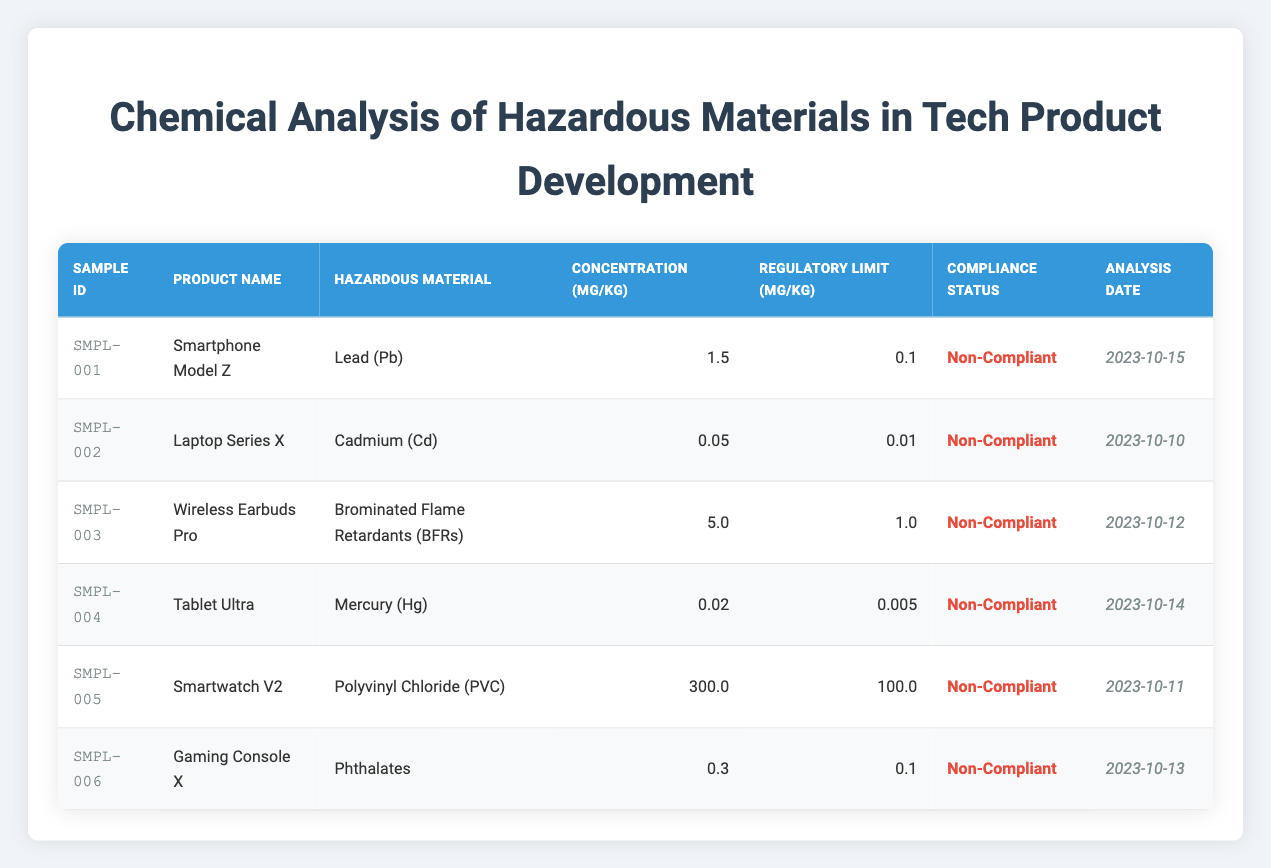What is the hazardous material found in Smartphone Model Z? The table lists the hazardous materials for each product. For Smartphone Model Z, the hazardous material is specified in the "Hazardous Material" column, which shows "Lead (Pb)."
Answer: Lead (Pb) Which product has the highest concentration of hazardous material? To find the highest concentration, we look at the "Concentration (mg/kg)" column for all products. The maximum value is 300.0 from Smartwatch V2.
Answer: Smartwatch V2 Is Cadmium present in any compliant product? We check the "Compliance Status" column for any instance where the compliance status is "Compliant" and refer to the "Hazardous Material" associated with that product. Since "Non-Compliant" is the status for Laptop Series X (Cadmium), there are none compliant.
Answer: No What is the average concentration of hazardous materials in the analyzed products? We sum the concentrations (1.5 + 0.05 + 5.0 + 0.02 + 300.0 + 0.3 = 306.87) and divide by the total number of products (6). So, the average is 306.87 / 6 = 51.145.
Answer: 51.145 How many products are identified as Non-Compliant? We count the number of times "Non-Compliant" appears in the "Compliance Status" column. All six products listed are marked as Non-Compliant.
Answer: 6 Which product's hazardous material concentration is closest to its regulatory limit? By comparing the difference between concentration and regulatory limit for each product, we find that Tablet Ultra has the smallest difference (0.02 - 0.005 = 0.015 mg/kg).
Answer: Tablet Ultra Does any product exceed its regulatory limit by more than 100 mg per kg? We check which products have a concentration greater than their regulatory limit. Smartwatch V2 exceeds by 200 mg (300.0 - 100.0). Yes, so at least one product exceeds over 100 mg/kg.
Answer: Yes What is the regulatory limit for Brominated Flame Retardants (BFRs)? The table provides a specific value for each hazardous material in the "Regulatory Limit (mg/kg)" column. For BFRs, the regulatory limit is 1.0 mg/kg.
Answer: 1.0 mg/kg 